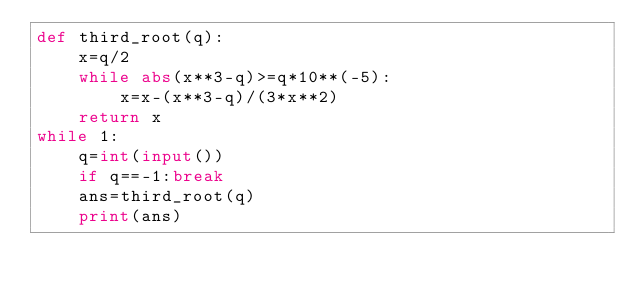Convert code to text. <code><loc_0><loc_0><loc_500><loc_500><_Python_>def third_root(q):
    x=q/2
    while abs(x**3-q)>=q*10**(-5):
        x=x-(x**3-q)/(3*x**2)
    return x
while 1:
    q=int(input())
    if q==-1:break
    ans=third_root(q)
    print(ans)</code> 